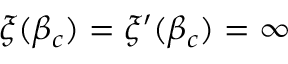<formula> <loc_0><loc_0><loc_500><loc_500>\xi ( \beta _ { c } ) = \xi ^ { \prime } ( \beta _ { c } ) = \infty</formula> 